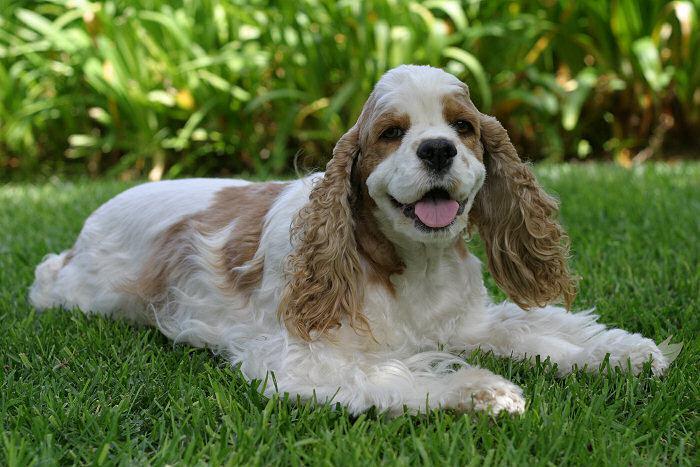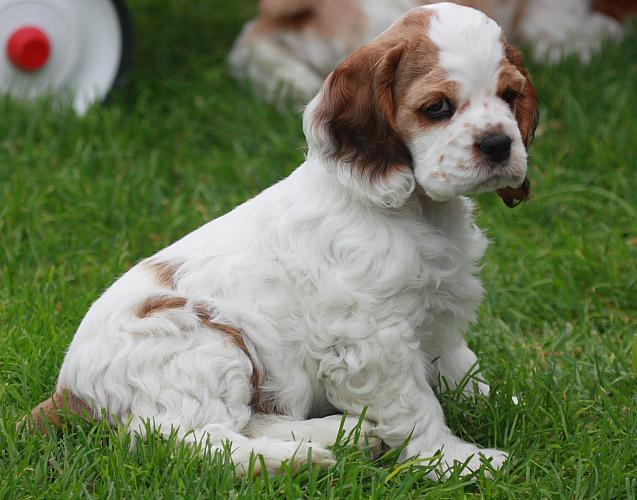The first image is the image on the left, the second image is the image on the right. Analyze the images presented: Is the assertion "Right image shows one dog on green grass, and the dog has white fur on its face with darker fur on its earsand around its eyes." valid? Answer yes or no. Yes. The first image is the image on the left, the second image is the image on the right. For the images shown, is this caption "The dogs in both images are sitting on the grass." true? Answer yes or no. Yes. 